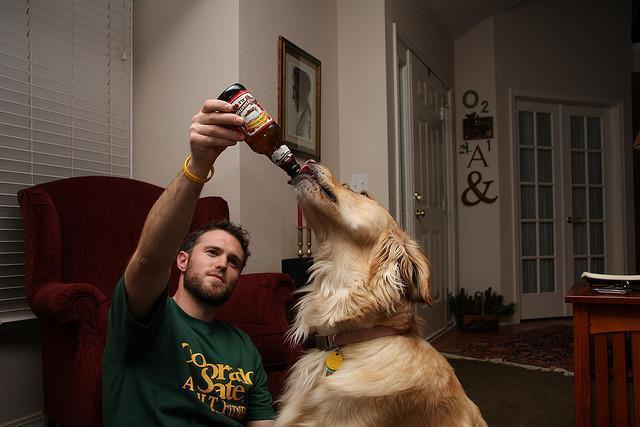How many potted plants are there?
Give a very brief answer. 1. 